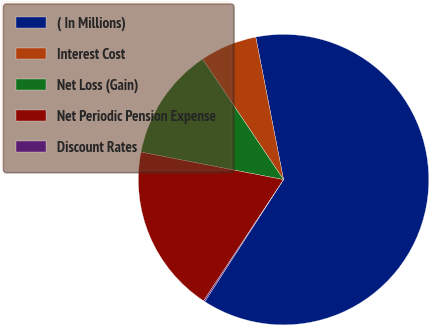Convert chart. <chart><loc_0><loc_0><loc_500><loc_500><pie_chart><fcel>( In Millions)<fcel>Interest Cost<fcel>Net Loss (Gain)<fcel>Net Periodic Pension Expense<fcel>Discount Rates<nl><fcel>62.19%<fcel>6.35%<fcel>12.55%<fcel>18.76%<fcel>0.15%<nl></chart> 